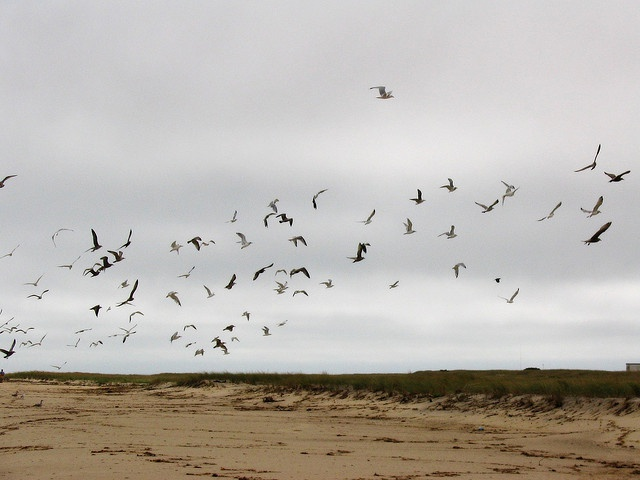Describe the objects in this image and their specific colors. I can see bird in lightgray, darkgray, and gray tones, bird in lightgray, darkgray, black, and gray tones, bird in lightgray, darkgray, and gray tones, bird in lightgray, gray, and darkgray tones, and bird in lightgray, black, gray, and darkgray tones in this image. 